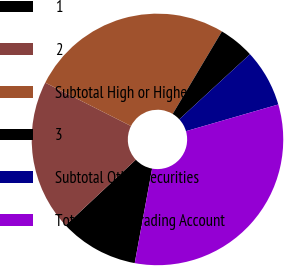Convert chart to OTSL. <chart><loc_0><loc_0><loc_500><loc_500><pie_chart><fcel>1<fcel>2<fcel>Subtotal High or Highest<fcel>3<fcel>Subtotal Other Securities<fcel>Total Private Trading Account<nl><fcel>10.14%<fcel>19.42%<fcel>26.11%<fcel>4.59%<fcel>7.37%<fcel>32.38%<nl></chart> 